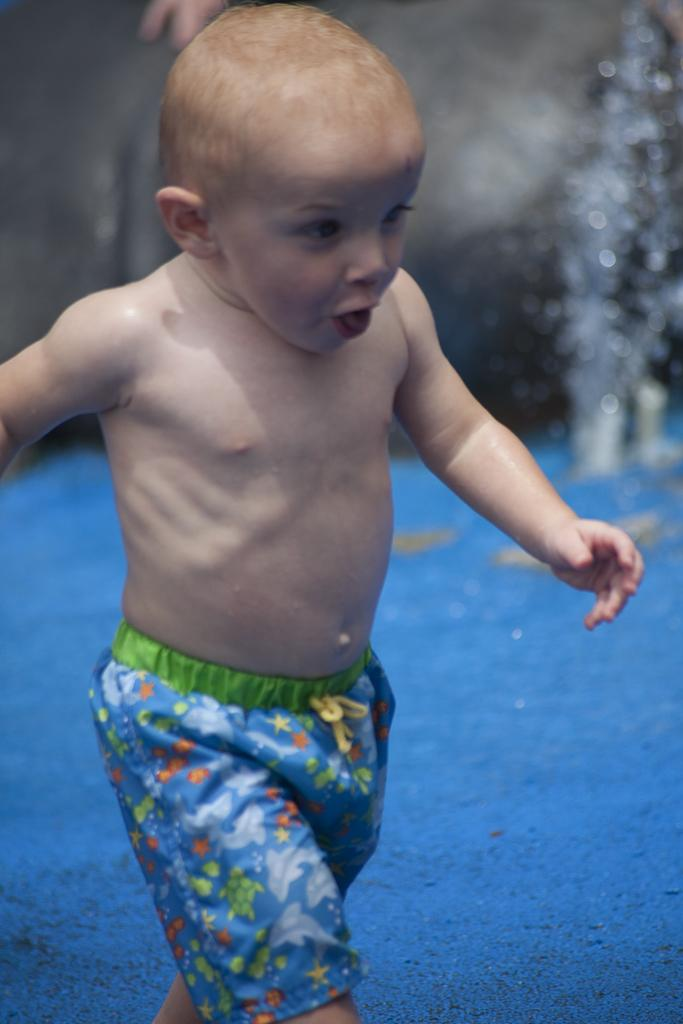Who is the main subject in the image? There is a boy in the image. What is the boy doing in the image? The boy is walking. Can you describe the background of the image? The background of the image is blurry. What can be seen in the background of the image? There is water visible in the background of the image. What type of game is the boy playing in the image? There is no game visible in the image; the boy is simply walking. What boundary can be seen in the image? There is no boundary present in the image. 